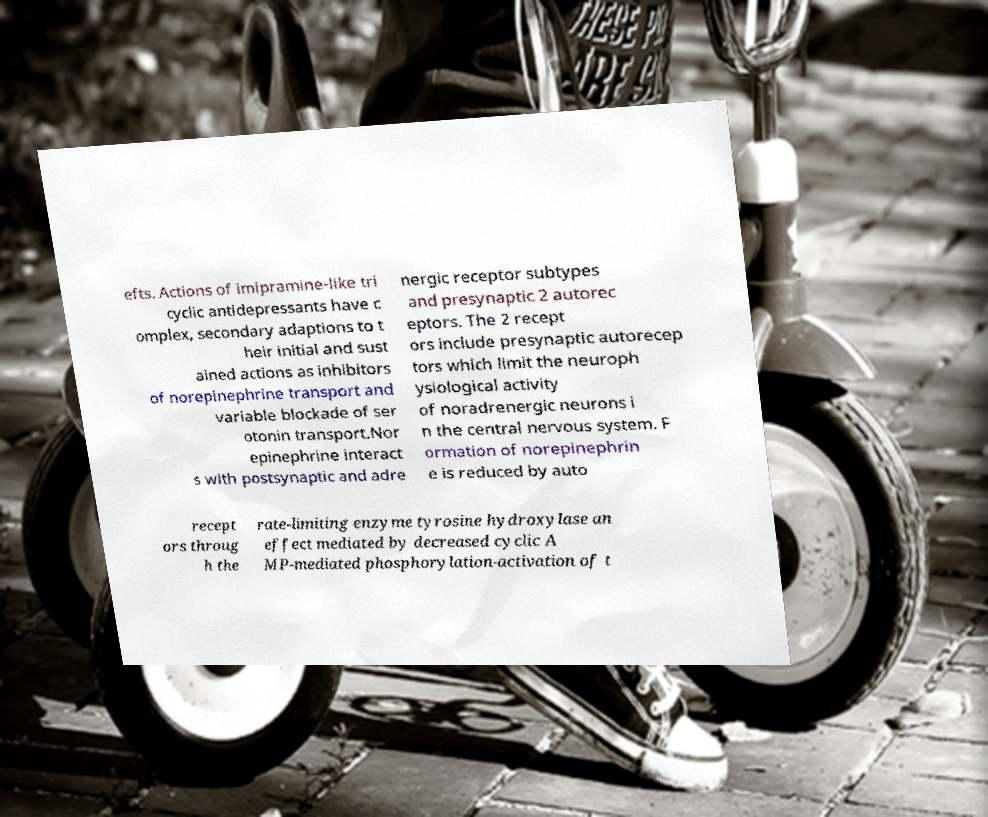There's text embedded in this image that I need extracted. Can you transcribe it verbatim? efts. Actions of imipramine-like tri cyclic antidepressants have c omplex, secondary adaptions to t heir initial and sust ained actions as inhibitors of norepinephrine transport and variable blockade of ser otonin transport.Nor epinephrine interact s with postsynaptic and adre nergic receptor subtypes and presynaptic 2 autorec eptors. The 2 recept ors include presynaptic autorecep tors which limit the neuroph ysiological activity of noradrenergic neurons i n the central nervous system. F ormation of norepinephrin e is reduced by auto recept ors throug h the rate-limiting enzyme tyrosine hydroxylase an effect mediated by decreased cyclic A MP-mediated phosphorylation-activation of t 